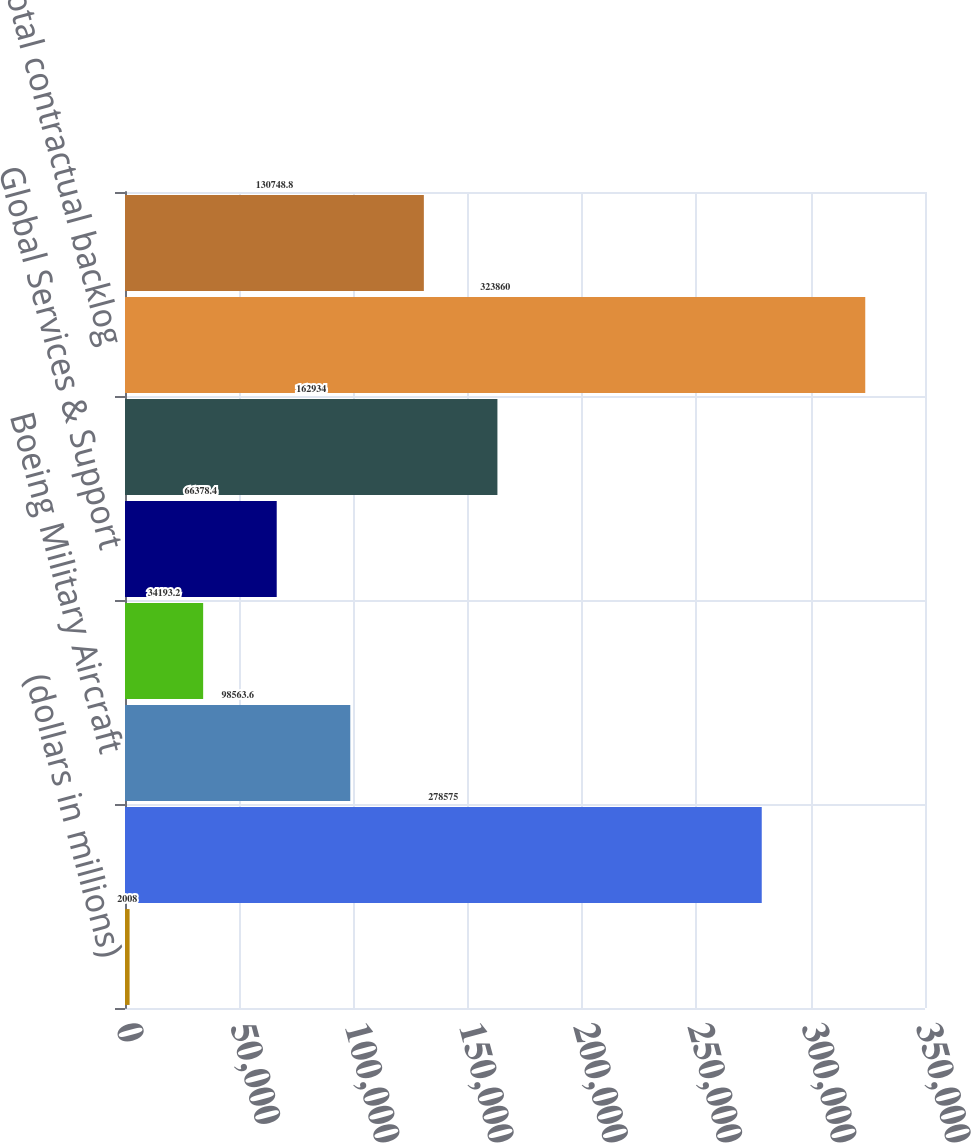Convert chart to OTSL. <chart><loc_0><loc_0><loc_500><loc_500><bar_chart><fcel>(dollars in millions)<fcel>Commercial Airplanes<fcel>Boeing Military Aircraft<fcel>Network & Space Systems<fcel>Global Services & Support<fcel>Total Boeing Defense Space &<fcel>Total contractual backlog<fcel>Unobligated backlog<nl><fcel>2008<fcel>278575<fcel>98563.6<fcel>34193.2<fcel>66378.4<fcel>162934<fcel>323860<fcel>130749<nl></chart> 